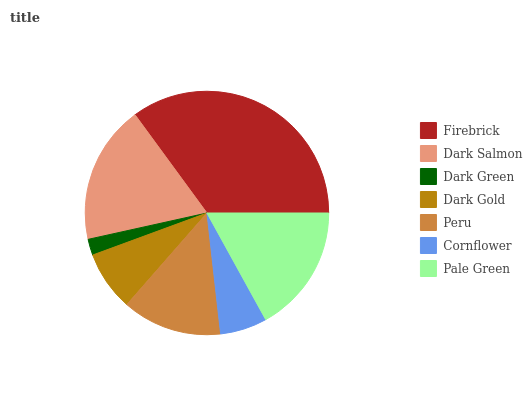Is Dark Green the minimum?
Answer yes or no. Yes. Is Firebrick the maximum?
Answer yes or no. Yes. Is Dark Salmon the minimum?
Answer yes or no. No. Is Dark Salmon the maximum?
Answer yes or no. No. Is Firebrick greater than Dark Salmon?
Answer yes or no. Yes. Is Dark Salmon less than Firebrick?
Answer yes or no. Yes. Is Dark Salmon greater than Firebrick?
Answer yes or no. No. Is Firebrick less than Dark Salmon?
Answer yes or no. No. Is Peru the high median?
Answer yes or no. Yes. Is Peru the low median?
Answer yes or no. Yes. Is Dark Salmon the high median?
Answer yes or no. No. Is Dark Gold the low median?
Answer yes or no. No. 